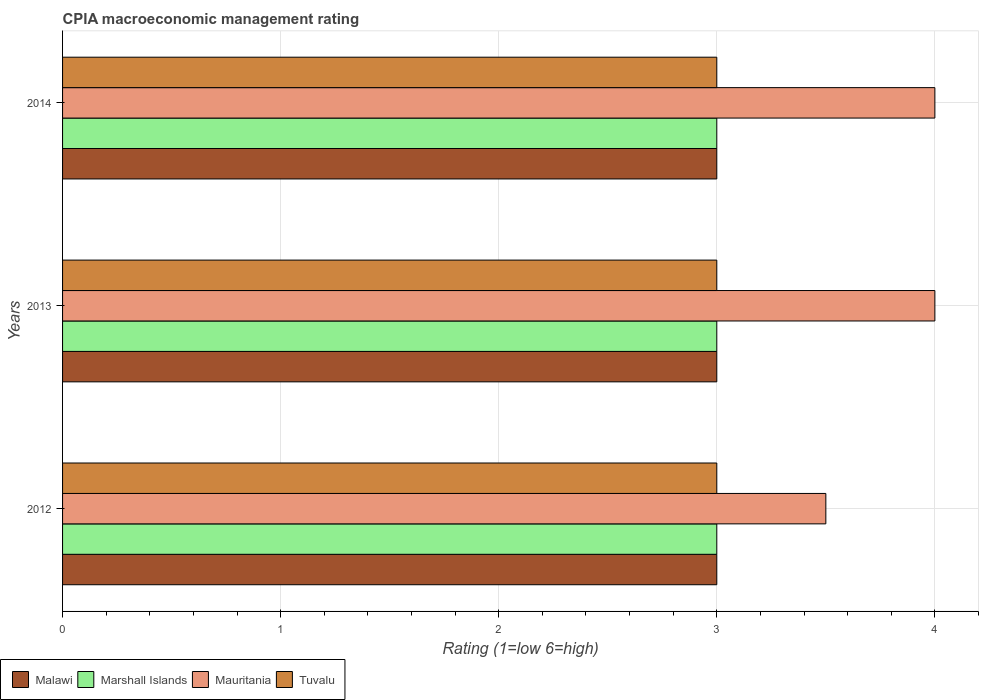How many groups of bars are there?
Make the answer very short. 3. Are the number of bars per tick equal to the number of legend labels?
Offer a very short reply. Yes. Are the number of bars on each tick of the Y-axis equal?
Ensure brevity in your answer.  Yes. How many bars are there on the 2nd tick from the top?
Your answer should be compact. 4. How many bars are there on the 2nd tick from the bottom?
Give a very brief answer. 4. What is the CPIA rating in Tuvalu in 2013?
Keep it short and to the point. 3. In which year was the CPIA rating in Tuvalu maximum?
Make the answer very short. 2012. In which year was the CPIA rating in Malawi minimum?
Ensure brevity in your answer.  2012. What is the difference between the CPIA rating in Mauritania in 2014 and the CPIA rating in Marshall Islands in 2012?
Offer a very short reply. 1. In the year 2012, what is the difference between the CPIA rating in Malawi and CPIA rating in Marshall Islands?
Provide a succinct answer. 0. In how many years, is the CPIA rating in Malawi greater than 2.2 ?
Provide a succinct answer. 3. Is the CPIA rating in Tuvalu in 2013 less than that in 2014?
Give a very brief answer. No. Is the difference between the CPIA rating in Malawi in 2012 and 2014 greater than the difference between the CPIA rating in Marshall Islands in 2012 and 2014?
Provide a succinct answer. No. What is the difference between the highest and the lowest CPIA rating in Tuvalu?
Provide a succinct answer. 0. Is the sum of the CPIA rating in Marshall Islands in 2012 and 2013 greater than the maximum CPIA rating in Mauritania across all years?
Your answer should be compact. Yes. Is it the case that in every year, the sum of the CPIA rating in Malawi and CPIA rating in Tuvalu is greater than the sum of CPIA rating in Marshall Islands and CPIA rating in Mauritania?
Ensure brevity in your answer.  No. What does the 3rd bar from the top in 2012 represents?
Your response must be concise. Marshall Islands. What does the 4th bar from the bottom in 2014 represents?
Provide a succinct answer. Tuvalu. Is it the case that in every year, the sum of the CPIA rating in Malawi and CPIA rating in Tuvalu is greater than the CPIA rating in Marshall Islands?
Offer a terse response. Yes. Are all the bars in the graph horizontal?
Keep it short and to the point. Yes. How many years are there in the graph?
Your response must be concise. 3. Does the graph contain grids?
Your response must be concise. Yes. Where does the legend appear in the graph?
Offer a very short reply. Bottom left. How many legend labels are there?
Keep it short and to the point. 4. How are the legend labels stacked?
Provide a succinct answer. Horizontal. What is the title of the graph?
Give a very brief answer. CPIA macroeconomic management rating. Does "Sub-Saharan Africa (developing only)" appear as one of the legend labels in the graph?
Your answer should be compact. No. What is the label or title of the X-axis?
Make the answer very short. Rating (1=low 6=high). What is the label or title of the Y-axis?
Offer a terse response. Years. What is the Rating (1=low 6=high) of Marshall Islands in 2012?
Offer a terse response. 3. What is the Rating (1=low 6=high) of Mauritania in 2012?
Provide a succinct answer. 3.5. What is the Rating (1=low 6=high) in Malawi in 2013?
Offer a terse response. 3. What is the Rating (1=low 6=high) in Marshall Islands in 2013?
Ensure brevity in your answer.  3. What is the Rating (1=low 6=high) of Tuvalu in 2013?
Ensure brevity in your answer.  3. What is the Rating (1=low 6=high) in Malawi in 2014?
Your answer should be very brief. 3. What is the Rating (1=low 6=high) of Tuvalu in 2014?
Keep it short and to the point. 3. Across all years, what is the maximum Rating (1=low 6=high) in Malawi?
Ensure brevity in your answer.  3. Across all years, what is the minimum Rating (1=low 6=high) in Malawi?
Ensure brevity in your answer.  3. Across all years, what is the minimum Rating (1=low 6=high) of Mauritania?
Provide a succinct answer. 3.5. Across all years, what is the minimum Rating (1=low 6=high) of Tuvalu?
Offer a terse response. 3. What is the total Rating (1=low 6=high) of Malawi in the graph?
Provide a short and direct response. 9. What is the total Rating (1=low 6=high) of Tuvalu in the graph?
Provide a short and direct response. 9. What is the difference between the Rating (1=low 6=high) of Marshall Islands in 2012 and that in 2013?
Keep it short and to the point. 0. What is the difference between the Rating (1=low 6=high) in Tuvalu in 2012 and that in 2013?
Provide a short and direct response. 0. What is the difference between the Rating (1=low 6=high) in Tuvalu in 2012 and that in 2014?
Make the answer very short. 0. What is the difference between the Rating (1=low 6=high) of Mauritania in 2013 and that in 2014?
Your response must be concise. 0. What is the difference between the Rating (1=low 6=high) of Tuvalu in 2013 and that in 2014?
Give a very brief answer. 0. What is the difference between the Rating (1=low 6=high) of Malawi in 2012 and the Rating (1=low 6=high) of Marshall Islands in 2013?
Provide a succinct answer. 0. What is the difference between the Rating (1=low 6=high) of Malawi in 2012 and the Rating (1=low 6=high) of Mauritania in 2013?
Provide a short and direct response. -1. What is the difference between the Rating (1=low 6=high) in Marshall Islands in 2012 and the Rating (1=low 6=high) in Mauritania in 2013?
Offer a terse response. -1. What is the difference between the Rating (1=low 6=high) in Malawi in 2012 and the Rating (1=low 6=high) in Marshall Islands in 2014?
Keep it short and to the point. 0. What is the difference between the Rating (1=low 6=high) in Malawi in 2012 and the Rating (1=low 6=high) in Mauritania in 2014?
Your answer should be compact. -1. What is the difference between the Rating (1=low 6=high) of Marshall Islands in 2012 and the Rating (1=low 6=high) of Mauritania in 2014?
Your response must be concise. -1. What is the difference between the Rating (1=low 6=high) in Marshall Islands in 2012 and the Rating (1=low 6=high) in Tuvalu in 2014?
Give a very brief answer. 0. What is the difference between the Rating (1=low 6=high) in Malawi in 2013 and the Rating (1=low 6=high) in Marshall Islands in 2014?
Offer a terse response. 0. What is the difference between the Rating (1=low 6=high) of Marshall Islands in 2013 and the Rating (1=low 6=high) of Mauritania in 2014?
Make the answer very short. -1. What is the average Rating (1=low 6=high) of Marshall Islands per year?
Offer a terse response. 3. What is the average Rating (1=low 6=high) in Mauritania per year?
Make the answer very short. 3.83. What is the average Rating (1=low 6=high) of Tuvalu per year?
Ensure brevity in your answer.  3. In the year 2012, what is the difference between the Rating (1=low 6=high) in Malawi and Rating (1=low 6=high) in Marshall Islands?
Give a very brief answer. 0. In the year 2012, what is the difference between the Rating (1=low 6=high) in Malawi and Rating (1=low 6=high) in Tuvalu?
Keep it short and to the point. 0. In the year 2012, what is the difference between the Rating (1=low 6=high) of Marshall Islands and Rating (1=low 6=high) of Mauritania?
Give a very brief answer. -0.5. In the year 2013, what is the difference between the Rating (1=low 6=high) of Malawi and Rating (1=low 6=high) of Marshall Islands?
Ensure brevity in your answer.  0. In the year 2013, what is the difference between the Rating (1=low 6=high) of Malawi and Rating (1=low 6=high) of Mauritania?
Your answer should be very brief. -1. In the year 2013, what is the difference between the Rating (1=low 6=high) in Malawi and Rating (1=low 6=high) in Tuvalu?
Ensure brevity in your answer.  0. In the year 2013, what is the difference between the Rating (1=low 6=high) in Marshall Islands and Rating (1=low 6=high) in Mauritania?
Keep it short and to the point. -1. In the year 2013, what is the difference between the Rating (1=low 6=high) in Marshall Islands and Rating (1=low 6=high) in Tuvalu?
Offer a terse response. 0. In the year 2013, what is the difference between the Rating (1=low 6=high) in Mauritania and Rating (1=low 6=high) in Tuvalu?
Ensure brevity in your answer.  1. In the year 2014, what is the difference between the Rating (1=low 6=high) of Malawi and Rating (1=low 6=high) of Mauritania?
Make the answer very short. -1. In the year 2014, what is the difference between the Rating (1=low 6=high) in Malawi and Rating (1=low 6=high) in Tuvalu?
Offer a terse response. 0. In the year 2014, what is the difference between the Rating (1=low 6=high) in Marshall Islands and Rating (1=low 6=high) in Mauritania?
Your answer should be compact. -1. In the year 2014, what is the difference between the Rating (1=low 6=high) in Marshall Islands and Rating (1=low 6=high) in Tuvalu?
Provide a short and direct response. 0. In the year 2014, what is the difference between the Rating (1=low 6=high) in Mauritania and Rating (1=low 6=high) in Tuvalu?
Offer a terse response. 1. What is the ratio of the Rating (1=low 6=high) in Malawi in 2012 to that in 2013?
Offer a terse response. 1. What is the ratio of the Rating (1=low 6=high) of Marshall Islands in 2012 to that in 2013?
Your response must be concise. 1. What is the ratio of the Rating (1=low 6=high) of Mauritania in 2012 to that in 2013?
Give a very brief answer. 0.88. What is the ratio of the Rating (1=low 6=high) of Mauritania in 2012 to that in 2014?
Your response must be concise. 0.88. What is the ratio of the Rating (1=low 6=high) of Tuvalu in 2012 to that in 2014?
Offer a terse response. 1. What is the ratio of the Rating (1=low 6=high) of Malawi in 2013 to that in 2014?
Your response must be concise. 1. What is the ratio of the Rating (1=low 6=high) in Tuvalu in 2013 to that in 2014?
Offer a terse response. 1. What is the difference between the highest and the second highest Rating (1=low 6=high) in Mauritania?
Offer a very short reply. 0. What is the difference between the highest and the second highest Rating (1=low 6=high) in Tuvalu?
Make the answer very short. 0. What is the difference between the highest and the lowest Rating (1=low 6=high) of Malawi?
Offer a very short reply. 0. What is the difference between the highest and the lowest Rating (1=low 6=high) in Marshall Islands?
Offer a terse response. 0. 